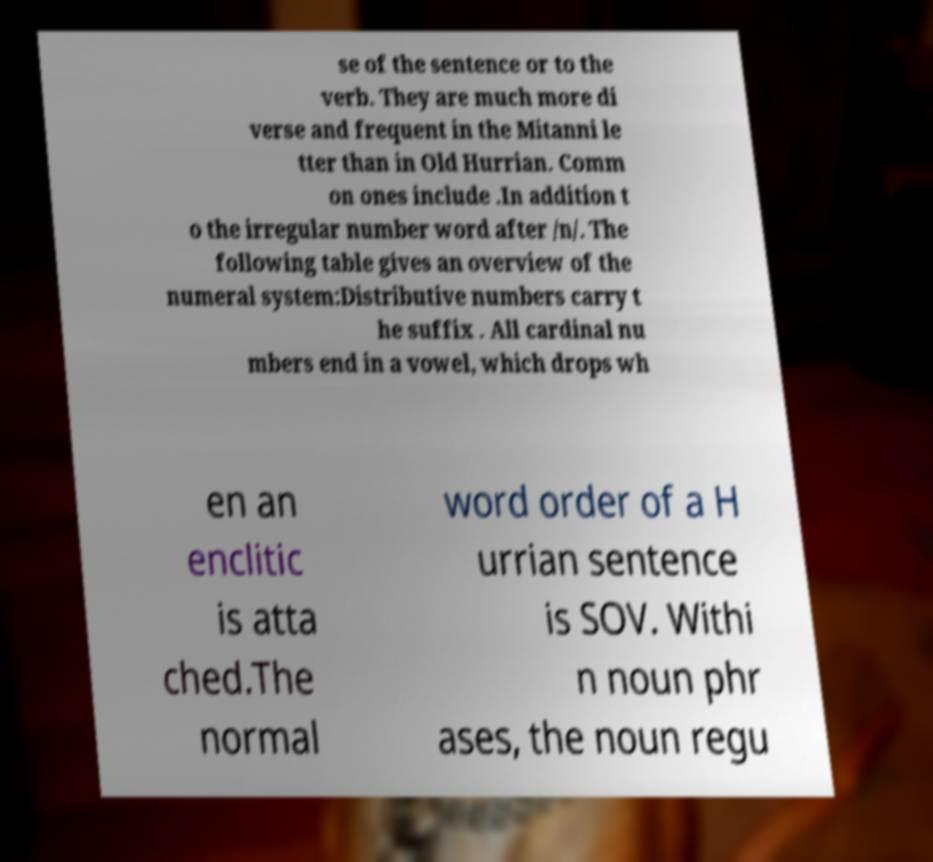Can you read and provide the text displayed in the image?This photo seems to have some interesting text. Can you extract and type it out for me? se of the sentence or to the verb. They are much more di verse and frequent in the Mitanni le tter than in Old Hurrian. Comm on ones include .In addition t o the irregular number word after /n/. The following table gives an overview of the numeral system:Distributive numbers carry t he suffix . All cardinal nu mbers end in a vowel, which drops wh en an enclitic is atta ched.The normal word order of a H urrian sentence is SOV. Withi n noun phr ases, the noun regu 